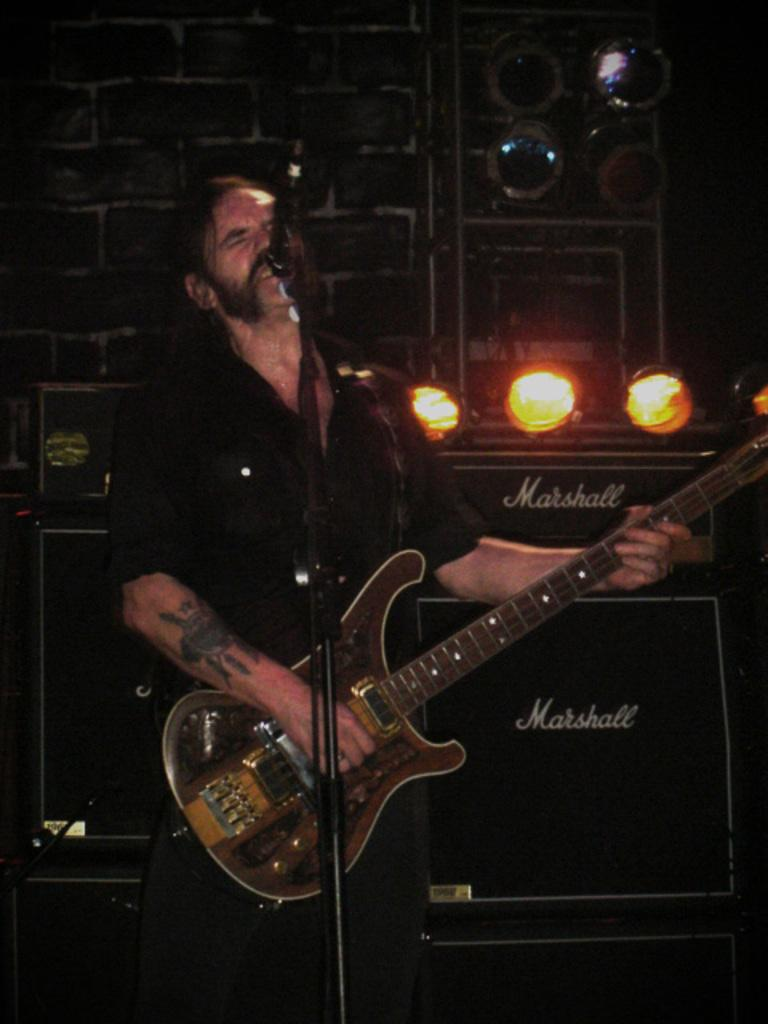Who is the main subject in the image? There is a man in the image. What is the man doing in the image? The man is standing in front of a microphone and playing a guitar. What can be seen in the background of the image? There is a wall in the background of the image. What else is visible in the image besides the man and the wall? There are lights visible in the image. What type of clover is the man holding in his hand while playing the guitar? There is no clover present in the image; the man is playing a guitar and standing in front of a microphone. What type of throne is the man sitting on while playing the guitar? There is no throne present in the image; the man is standing in front of a microphone while playing the guitar. 